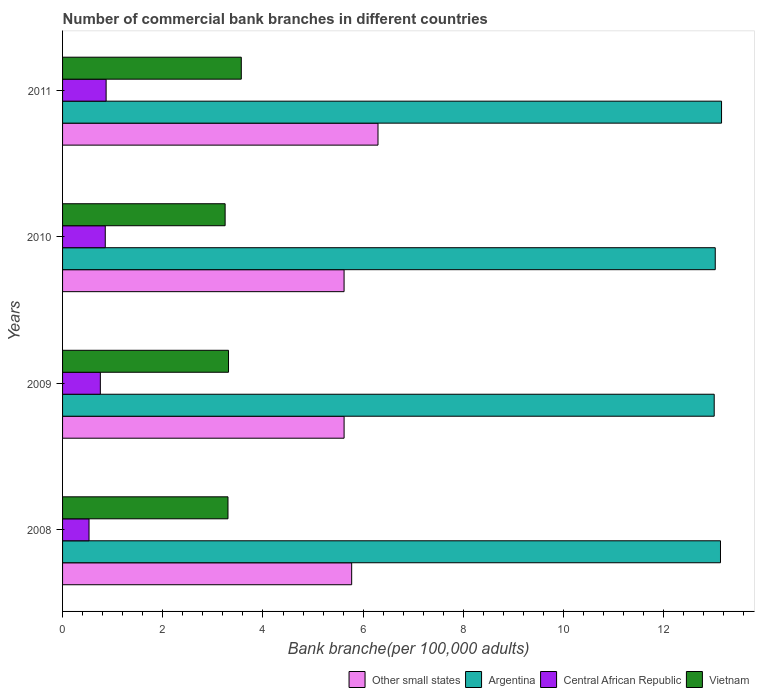How many different coloured bars are there?
Your answer should be compact. 4. How many groups of bars are there?
Provide a short and direct response. 4. Are the number of bars on each tick of the Y-axis equal?
Your answer should be compact. Yes. How many bars are there on the 4th tick from the bottom?
Provide a short and direct response. 4. In how many cases, is the number of bars for a given year not equal to the number of legend labels?
Provide a short and direct response. 0. What is the number of commercial bank branches in Other small states in 2008?
Give a very brief answer. 5.77. Across all years, what is the maximum number of commercial bank branches in Vietnam?
Your response must be concise. 3.57. Across all years, what is the minimum number of commercial bank branches in Central African Republic?
Ensure brevity in your answer.  0.53. What is the total number of commercial bank branches in Argentina in the graph?
Offer a very short reply. 52.32. What is the difference between the number of commercial bank branches in Argentina in 2008 and that in 2009?
Offer a terse response. 0.13. What is the difference between the number of commercial bank branches in Other small states in 2010 and the number of commercial bank branches in Vietnam in 2009?
Offer a terse response. 2.31. What is the average number of commercial bank branches in Other small states per year?
Make the answer very short. 5.83. In the year 2008, what is the difference between the number of commercial bank branches in Central African Republic and number of commercial bank branches in Argentina?
Your response must be concise. -12.6. What is the ratio of the number of commercial bank branches in Other small states in 2009 to that in 2011?
Provide a short and direct response. 0.89. Is the number of commercial bank branches in Argentina in 2008 less than that in 2011?
Offer a terse response. Yes. Is the difference between the number of commercial bank branches in Central African Republic in 2009 and 2010 greater than the difference between the number of commercial bank branches in Argentina in 2009 and 2010?
Provide a short and direct response. No. What is the difference between the highest and the second highest number of commercial bank branches in Vietnam?
Offer a very short reply. 0.26. What is the difference between the highest and the lowest number of commercial bank branches in Other small states?
Offer a very short reply. 0.68. In how many years, is the number of commercial bank branches in Argentina greater than the average number of commercial bank branches in Argentina taken over all years?
Make the answer very short. 2. What does the 3rd bar from the bottom in 2008 represents?
Offer a very short reply. Central African Republic. Is it the case that in every year, the sum of the number of commercial bank branches in Other small states and number of commercial bank branches in Argentina is greater than the number of commercial bank branches in Central African Republic?
Your answer should be very brief. Yes. How many bars are there?
Keep it short and to the point. 16. Are all the bars in the graph horizontal?
Offer a terse response. Yes. Are the values on the major ticks of X-axis written in scientific E-notation?
Give a very brief answer. No. Does the graph contain grids?
Keep it short and to the point. No. How are the legend labels stacked?
Keep it short and to the point. Horizontal. What is the title of the graph?
Offer a very short reply. Number of commercial bank branches in different countries. What is the label or title of the X-axis?
Make the answer very short. Bank branche(per 100,0 adults). What is the label or title of the Y-axis?
Keep it short and to the point. Years. What is the Bank branche(per 100,000 adults) in Other small states in 2008?
Provide a short and direct response. 5.77. What is the Bank branche(per 100,000 adults) in Argentina in 2008?
Your answer should be very brief. 13.13. What is the Bank branche(per 100,000 adults) of Central African Republic in 2008?
Keep it short and to the point. 0.53. What is the Bank branche(per 100,000 adults) in Vietnam in 2008?
Give a very brief answer. 3.3. What is the Bank branche(per 100,000 adults) in Other small states in 2009?
Your response must be concise. 5.62. What is the Bank branche(per 100,000 adults) in Argentina in 2009?
Ensure brevity in your answer.  13.01. What is the Bank branche(per 100,000 adults) in Central African Republic in 2009?
Make the answer very short. 0.75. What is the Bank branche(per 100,000 adults) of Vietnam in 2009?
Provide a succinct answer. 3.31. What is the Bank branche(per 100,000 adults) in Other small states in 2010?
Offer a terse response. 5.62. What is the Bank branche(per 100,000 adults) in Argentina in 2010?
Offer a very short reply. 13.03. What is the Bank branche(per 100,000 adults) in Central African Republic in 2010?
Offer a terse response. 0.85. What is the Bank branche(per 100,000 adults) in Vietnam in 2010?
Offer a very short reply. 3.24. What is the Bank branche(per 100,000 adults) of Other small states in 2011?
Provide a short and direct response. 6.3. What is the Bank branche(per 100,000 adults) in Argentina in 2011?
Make the answer very short. 13.15. What is the Bank branche(per 100,000 adults) of Central African Republic in 2011?
Provide a short and direct response. 0.87. What is the Bank branche(per 100,000 adults) in Vietnam in 2011?
Your response must be concise. 3.57. Across all years, what is the maximum Bank branche(per 100,000 adults) of Other small states?
Your answer should be very brief. 6.3. Across all years, what is the maximum Bank branche(per 100,000 adults) in Argentina?
Provide a short and direct response. 13.15. Across all years, what is the maximum Bank branche(per 100,000 adults) of Central African Republic?
Your answer should be compact. 0.87. Across all years, what is the maximum Bank branche(per 100,000 adults) of Vietnam?
Your response must be concise. 3.57. Across all years, what is the minimum Bank branche(per 100,000 adults) of Other small states?
Make the answer very short. 5.62. Across all years, what is the minimum Bank branche(per 100,000 adults) in Argentina?
Your answer should be compact. 13.01. Across all years, what is the minimum Bank branche(per 100,000 adults) in Central African Republic?
Your answer should be compact. 0.53. Across all years, what is the minimum Bank branche(per 100,000 adults) of Vietnam?
Offer a terse response. 3.24. What is the total Bank branche(per 100,000 adults) of Other small states in the graph?
Ensure brevity in your answer.  23.3. What is the total Bank branche(per 100,000 adults) of Argentina in the graph?
Make the answer very short. 52.32. What is the total Bank branche(per 100,000 adults) in Central African Republic in the graph?
Keep it short and to the point. 3. What is the total Bank branche(per 100,000 adults) in Vietnam in the graph?
Keep it short and to the point. 13.43. What is the difference between the Bank branche(per 100,000 adults) of Other small states in 2008 and that in 2009?
Offer a very short reply. 0.15. What is the difference between the Bank branche(per 100,000 adults) in Argentina in 2008 and that in 2009?
Give a very brief answer. 0.13. What is the difference between the Bank branche(per 100,000 adults) in Central African Republic in 2008 and that in 2009?
Offer a terse response. -0.23. What is the difference between the Bank branche(per 100,000 adults) in Vietnam in 2008 and that in 2009?
Keep it short and to the point. -0.01. What is the difference between the Bank branche(per 100,000 adults) of Other small states in 2008 and that in 2010?
Your answer should be very brief. 0.15. What is the difference between the Bank branche(per 100,000 adults) in Argentina in 2008 and that in 2010?
Offer a very short reply. 0.1. What is the difference between the Bank branche(per 100,000 adults) of Central African Republic in 2008 and that in 2010?
Offer a terse response. -0.32. What is the difference between the Bank branche(per 100,000 adults) of Vietnam in 2008 and that in 2010?
Give a very brief answer. 0.06. What is the difference between the Bank branche(per 100,000 adults) of Other small states in 2008 and that in 2011?
Your response must be concise. -0.53. What is the difference between the Bank branche(per 100,000 adults) in Argentina in 2008 and that in 2011?
Make the answer very short. -0.02. What is the difference between the Bank branche(per 100,000 adults) in Central African Republic in 2008 and that in 2011?
Make the answer very short. -0.34. What is the difference between the Bank branche(per 100,000 adults) in Vietnam in 2008 and that in 2011?
Your response must be concise. -0.27. What is the difference between the Bank branche(per 100,000 adults) of Other small states in 2009 and that in 2010?
Provide a succinct answer. 0. What is the difference between the Bank branche(per 100,000 adults) of Argentina in 2009 and that in 2010?
Offer a terse response. -0.02. What is the difference between the Bank branche(per 100,000 adults) in Central African Republic in 2009 and that in 2010?
Your answer should be compact. -0.1. What is the difference between the Bank branche(per 100,000 adults) of Vietnam in 2009 and that in 2010?
Ensure brevity in your answer.  0.07. What is the difference between the Bank branche(per 100,000 adults) in Other small states in 2009 and that in 2011?
Your response must be concise. -0.68. What is the difference between the Bank branche(per 100,000 adults) in Argentina in 2009 and that in 2011?
Offer a very short reply. -0.15. What is the difference between the Bank branche(per 100,000 adults) of Central African Republic in 2009 and that in 2011?
Your answer should be very brief. -0.12. What is the difference between the Bank branche(per 100,000 adults) in Vietnam in 2009 and that in 2011?
Ensure brevity in your answer.  -0.26. What is the difference between the Bank branche(per 100,000 adults) of Other small states in 2010 and that in 2011?
Your answer should be very brief. -0.68. What is the difference between the Bank branche(per 100,000 adults) in Argentina in 2010 and that in 2011?
Provide a succinct answer. -0.13. What is the difference between the Bank branche(per 100,000 adults) in Central African Republic in 2010 and that in 2011?
Your answer should be compact. -0.02. What is the difference between the Bank branche(per 100,000 adults) of Vietnam in 2010 and that in 2011?
Your answer should be very brief. -0.32. What is the difference between the Bank branche(per 100,000 adults) in Other small states in 2008 and the Bank branche(per 100,000 adults) in Argentina in 2009?
Your response must be concise. -7.24. What is the difference between the Bank branche(per 100,000 adults) in Other small states in 2008 and the Bank branche(per 100,000 adults) in Central African Republic in 2009?
Offer a terse response. 5.02. What is the difference between the Bank branche(per 100,000 adults) of Other small states in 2008 and the Bank branche(per 100,000 adults) of Vietnam in 2009?
Your response must be concise. 2.46. What is the difference between the Bank branche(per 100,000 adults) of Argentina in 2008 and the Bank branche(per 100,000 adults) of Central African Republic in 2009?
Ensure brevity in your answer.  12.38. What is the difference between the Bank branche(per 100,000 adults) of Argentina in 2008 and the Bank branche(per 100,000 adults) of Vietnam in 2009?
Offer a very short reply. 9.82. What is the difference between the Bank branche(per 100,000 adults) of Central African Republic in 2008 and the Bank branche(per 100,000 adults) of Vietnam in 2009?
Make the answer very short. -2.78. What is the difference between the Bank branche(per 100,000 adults) in Other small states in 2008 and the Bank branche(per 100,000 adults) in Argentina in 2010?
Provide a succinct answer. -7.26. What is the difference between the Bank branche(per 100,000 adults) of Other small states in 2008 and the Bank branche(per 100,000 adults) of Central African Republic in 2010?
Your answer should be very brief. 4.92. What is the difference between the Bank branche(per 100,000 adults) of Other small states in 2008 and the Bank branche(per 100,000 adults) of Vietnam in 2010?
Provide a short and direct response. 2.53. What is the difference between the Bank branche(per 100,000 adults) in Argentina in 2008 and the Bank branche(per 100,000 adults) in Central African Republic in 2010?
Your answer should be compact. 12.28. What is the difference between the Bank branche(per 100,000 adults) of Argentina in 2008 and the Bank branche(per 100,000 adults) of Vietnam in 2010?
Offer a terse response. 9.89. What is the difference between the Bank branche(per 100,000 adults) in Central African Republic in 2008 and the Bank branche(per 100,000 adults) in Vietnam in 2010?
Your answer should be compact. -2.72. What is the difference between the Bank branche(per 100,000 adults) in Other small states in 2008 and the Bank branche(per 100,000 adults) in Argentina in 2011?
Your response must be concise. -7.38. What is the difference between the Bank branche(per 100,000 adults) of Other small states in 2008 and the Bank branche(per 100,000 adults) of Central African Republic in 2011?
Your answer should be compact. 4.9. What is the difference between the Bank branche(per 100,000 adults) in Other small states in 2008 and the Bank branche(per 100,000 adults) in Vietnam in 2011?
Make the answer very short. 2.2. What is the difference between the Bank branche(per 100,000 adults) in Argentina in 2008 and the Bank branche(per 100,000 adults) in Central African Republic in 2011?
Provide a short and direct response. 12.26. What is the difference between the Bank branche(per 100,000 adults) in Argentina in 2008 and the Bank branche(per 100,000 adults) in Vietnam in 2011?
Make the answer very short. 9.56. What is the difference between the Bank branche(per 100,000 adults) in Central African Republic in 2008 and the Bank branche(per 100,000 adults) in Vietnam in 2011?
Keep it short and to the point. -3.04. What is the difference between the Bank branche(per 100,000 adults) of Other small states in 2009 and the Bank branche(per 100,000 adults) of Argentina in 2010?
Your response must be concise. -7.41. What is the difference between the Bank branche(per 100,000 adults) in Other small states in 2009 and the Bank branche(per 100,000 adults) in Central African Republic in 2010?
Provide a succinct answer. 4.77. What is the difference between the Bank branche(per 100,000 adults) in Other small states in 2009 and the Bank branche(per 100,000 adults) in Vietnam in 2010?
Give a very brief answer. 2.37. What is the difference between the Bank branche(per 100,000 adults) of Argentina in 2009 and the Bank branche(per 100,000 adults) of Central African Republic in 2010?
Make the answer very short. 12.15. What is the difference between the Bank branche(per 100,000 adults) of Argentina in 2009 and the Bank branche(per 100,000 adults) of Vietnam in 2010?
Provide a short and direct response. 9.76. What is the difference between the Bank branche(per 100,000 adults) of Central African Republic in 2009 and the Bank branche(per 100,000 adults) of Vietnam in 2010?
Keep it short and to the point. -2.49. What is the difference between the Bank branche(per 100,000 adults) in Other small states in 2009 and the Bank branche(per 100,000 adults) in Argentina in 2011?
Give a very brief answer. -7.53. What is the difference between the Bank branche(per 100,000 adults) of Other small states in 2009 and the Bank branche(per 100,000 adults) of Central African Republic in 2011?
Your response must be concise. 4.75. What is the difference between the Bank branche(per 100,000 adults) of Other small states in 2009 and the Bank branche(per 100,000 adults) of Vietnam in 2011?
Provide a succinct answer. 2.05. What is the difference between the Bank branche(per 100,000 adults) of Argentina in 2009 and the Bank branche(per 100,000 adults) of Central African Republic in 2011?
Provide a succinct answer. 12.14. What is the difference between the Bank branche(per 100,000 adults) of Argentina in 2009 and the Bank branche(per 100,000 adults) of Vietnam in 2011?
Give a very brief answer. 9.44. What is the difference between the Bank branche(per 100,000 adults) in Central African Republic in 2009 and the Bank branche(per 100,000 adults) in Vietnam in 2011?
Make the answer very short. -2.81. What is the difference between the Bank branche(per 100,000 adults) of Other small states in 2010 and the Bank branche(per 100,000 adults) of Argentina in 2011?
Give a very brief answer. -7.53. What is the difference between the Bank branche(per 100,000 adults) in Other small states in 2010 and the Bank branche(per 100,000 adults) in Central African Republic in 2011?
Make the answer very short. 4.75. What is the difference between the Bank branche(per 100,000 adults) in Other small states in 2010 and the Bank branche(per 100,000 adults) in Vietnam in 2011?
Your response must be concise. 2.05. What is the difference between the Bank branche(per 100,000 adults) of Argentina in 2010 and the Bank branche(per 100,000 adults) of Central African Republic in 2011?
Provide a succinct answer. 12.16. What is the difference between the Bank branche(per 100,000 adults) of Argentina in 2010 and the Bank branche(per 100,000 adults) of Vietnam in 2011?
Give a very brief answer. 9.46. What is the difference between the Bank branche(per 100,000 adults) in Central African Republic in 2010 and the Bank branche(per 100,000 adults) in Vietnam in 2011?
Your answer should be compact. -2.71. What is the average Bank branche(per 100,000 adults) of Other small states per year?
Your response must be concise. 5.83. What is the average Bank branche(per 100,000 adults) in Argentina per year?
Your response must be concise. 13.08. What is the average Bank branche(per 100,000 adults) of Central African Republic per year?
Make the answer very short. 0.75. What is the average Bank branche(per 100,000 adults) in Vietnam per year?
Make the answer very short. 3.36. In the year 2008, what is the difference between the Bank branche(per 100,000 adults) in Other small states and Bank branche(per 100,000 adults) in Argentina?
Your response must be concise. -7.36. In the year 2008, what is the difference between the Bank branche(per 100,000 adults) of Other small states and Bank branche(per 100,000 adults) of Central African Republic?
Give a very brief answer. 5.24. In the year 2008, what is the difference between the Bank branche(per 100,000 adults) of Other small states and Bank branche(per 100,000 adults) of Vietnam?
Ensure brevity in your answer.  2.47. In the year 2008, what is the difference between the Bank branche(per 100,000 adults) in Argentina and Bank branche(per 100,000 adults) in Central African Republic?
Your response must be concise. 12.6. In the year 2008, what is the difference between the Bank branche(per 100,000 adults) in Argentina and Bank branche(per 100,000 adults) in Vietnam?
Your answer should be very brief. 9.83. In the year 2008, what is the difference between the Bank branche(per 100,000 adults) in Central African Republic and Bank branche(per 100,000 adults) in Vietnam?
Your answer should be very brief. -2.77. In the year 2009, what is the difference between the Bank branche(per 100,000 adults) of Other small states and Bank branche(per 100,000 adults) of Argentina?
Make the answer very short. -7.39. In the year 2009, what is the difference between the Bank branche(per 100,000 adults) in Other small states and Bank branche(per 100,000 adults) in Central African Republic?
Offer a terse response. 4.87. In the year 2009, what is the difference between the Bank branche(per 100,000 adults) of Other small states and Bank branche(per 100,000 adults) of Vietnam?
Ensure brevity in your answer.  2.31. In the year 2009, what is the difference between the Bank branche(per 100,000 adults) of Argentina and Bank branche(per 100,000 adults) of Central African Republic?
Make the answer very short. 12.25. In the year 2009, what is the difference between the Bank branche(per 100,000 adults) of Argentina and Bank branche(per 100,000 adults) of Vietnam?
Give a very brief answer. 9.69. In the year 2009, what is the difference between the Bank branche(per 100,000 adults) of Central African Republic and Bank branche(per 100,000 adults) of Vietnam?
Offer a very short reply. -2.56. In the year 2010, what is the difference between the Bank branche(per 100,000 adults) of Other small states and Bank branche(per 100,000 adults) of Argentina?
Keep it short and to the point. -7.41. In the year 2010, what is the difference between the Bank branche(per 100,000 adults) in Other small states and Bank branche(per 100,000 adults) in Central African Republic?
Give a very brief answer. 4.77. In the year 2010, what is the difference between the Bank branche(per 100,000 adults) in Other small states and Bank branche(per 100,000 adults) in Vietnam?
Give a very brief answer. 2.37. In the year 2010, what is the difference between the Bank branche(per 100,000 adults) of Argentina and Bank branche(per 100,000 adults) of Central African Republic?
Your answer should be very brief. 12.17. In the year 2010, what is the difference between the Bank branche(per 100,000 adults) of Argentina and Bank branche(per 100,000 adults) of Vietnam?
Provide a succinct answer. 9.78. In the year 2010, what is the difference between the Bank branche(per 100,000 adults) of Central African Republic and Bank branche(per 100,000 adults) of Vietnam?
Ensure brevity in your answer.  -2.39. In the year 2011, what is the difference between the Bank branche(per 100,000 adults) of Other small states and Bank branche(per 100,000 adults) of Argentina?
Give a very brief answer. -6.86. In the year 2011, what is the difference between the Bank branche(per 100,000 adults) in Other small states and Bank branche(per 100,000 adults) in Central African Republic?
Your response must be concise. 5.43. In the year 2011, what is the difference between the Bank branche(per 100,000 adults) in Other small states and Bank branche(per 100,000 adults) in Vietnam?
Keep it short and to the point. 2.73. In the year 2011, what is the difference between the Bank branche(per 100,000 adults) of Argentina and Bank branche(per 100,000 adults) of Central African Republic?
Your response must be concise. 12.28. In the year 2011, what is the difference between the Bank branche(per 100,000 adults) of Argentina and Bank branche(per 100,000 adults) of Vietnam?
Make the answer very short. 9.59. In the year 2011, what is the difference between the Bank branche(per 100,000 adults) of Central African Republic and Bank branche(per 100,000 adults) of Vietnam?
Give a very brief answer. -2.7. What is the ratio of the Bank branche(per 100,000 adults) of Other small states in 2008 to that in 2009?
Keep it short and to the point. 1.03. What is the ratio of the Bank branche(per 100,000 adults) in Argentina in 2008 to that in 2009?
Offer a very short reply. 1.01. What is the ratio of the Bank branche(per 100,000 adults) of Central African Republic in 2008 to that in 2009?
Provide a succinct answer. 0.7. What is the ratio of the Bank branche(per 100,000 adults) in Vietnam in 2008 to that in 2009?
Keep it short and to the point. 1. What is the ratio of the Bank branche(per 100,000 adults) of Argentina in 2008 to that in 2010?
Ensure brevity in your answer.  1.01. What is the ratio of the Bank branche(per 100,000 adults) in Central African Republic in 2008 to that in 2010?
Offer a terse response. 0.62. What is the ratio of the Bank branche(per 100,000 adults) in Vietnam in 2008 to that in 2010?
Make the answer very short. 1.02. What is the ratio of the Bank branche(per 100,000 adults) of Other small states in 2008 to that in 2011?
Make the answer very short. 0.92. What is the ratio of the Bank branche(per 100,000 adults) in Central African Republic in 2008 to that in 2011?
Offer a very short reply. 0.61. What is the ratio of the Bank branche(per 100,000 adults) in Vietnam in 2008 to that in 2011?
Provide a short and direct response. 0.93. What is the ratio of the Bank branche(per 100,000 adults) in Other small states in 2009 to that in 2010?
Give a very brief answer. 1. What is the ratio of the Bank branche(per 100,000 adults) of Argentina in 2009 to that in 2010?
Offer a terse response. 1. What is the ratio of the Bank branche(per 100,000 adults) of Central African Republic in 2009 to that in 2010?
Give a very brief answer. 0.88. What is the ratio of the Bank branche(per 100,000 adults) of Vietnam in 2009 to that in 2010?
Make the answer very short. 1.02. What is the ratio of the Bank branche(per 100,000 adults) in Other small states in 2009 to that in 2011?
Make the answer very short. 0.89. What is the ratio of the Bank branche(per 100,000 adults) of Argentina in 2009 to that in 2011?
Give a very brief answer. 0.99. What is the ratio of the Bank branche(per 100,000 adults) in Central African Republic in 2009 to that in 2011?
Keep it short and to the point. 0.87. What is the ratio of the Bank branche(per 100,000 adults) in Vietnam in 2009 to that in 2011?
Offer a very short reply. 0.93. What is the ratio of the Bank branche(per 100,000 adults) of Other small states in 2010 to that in 2011?
Provide a succinct answer. 0.89. What is the ratio of the Bank branche(per 100,000 adults) of Argentina in 2010 to that in 2011?
Make the answer very short. 0.99. What is the ratio of the Bank branche(per 100,000 adults) in Central African Republic in 2010 to that in 2011?
Keep it short and to the point. 0.98. What is the ratio of the Bank branche(per 100,000 adults) of Vietnam in 2010 to that in 2011?
Offer a very short reply. 0.91. What is the difference between the highest and the second highest Bank branche(per 100,000 adults) of Other small states?
Offer a very short reply. 0.53. What is the difference between the highest and the second highest Bank branche(per 100,000 adults) in Argentina?
Offer a terse response. 0.02. What is the difference between the highest and the second highest Bank branche(per 100,000 adults) of Central African Republic?
Your answer should be very brief. 0.02. What is the difference between the highest and the second highest Bank branche(per 100,000 adults) of Vietnam?
Provide a succinct answer. 0.26. What is the difference between the highest and the lowest Bank branche(per 100,000 adults) in Other small states?
Offer a terse response. 0.68. What is the difference between the highest and the lowest Bank branche(per 100,000 adults) in Argentina?
Keep it short and to the point. 0.15. What is the difference between the highest and the lowest Bank branche(per 100,000 adults) of Central African Republic?
Provide a short and direct response. 0.34. What is the difference between the highest and the lowest Bank branche(per 100,000 adults) of Vietnam?
Ensure brevity in your answer.  0.32. 